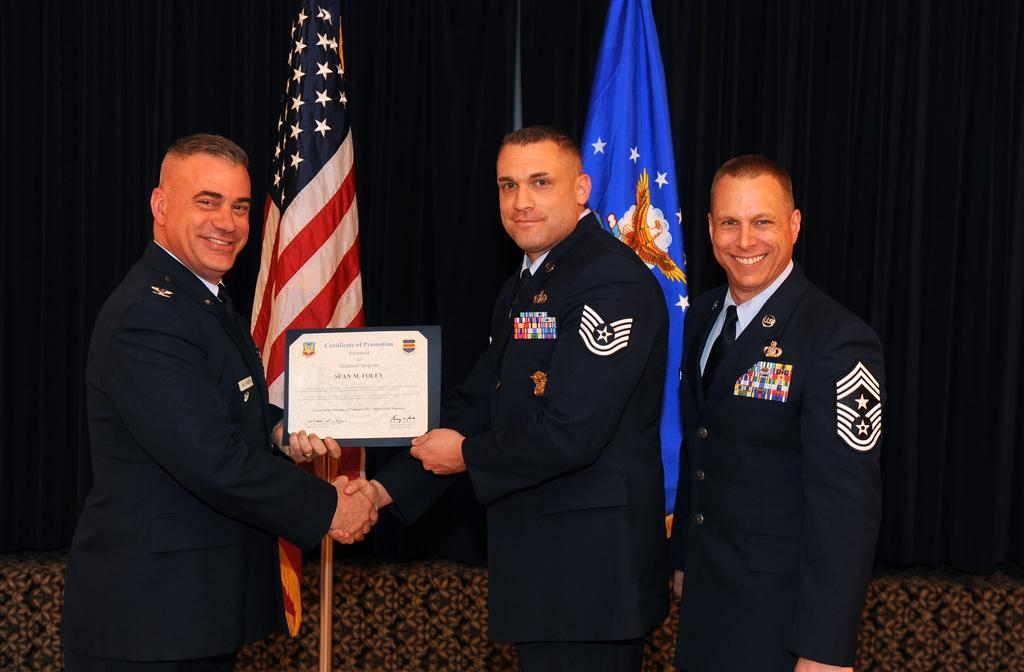How many people are in the image? There are three men in the image. What are the men doing in the image? The men are posing for a camera and smiling. What are the men holding in the image? The men are holding a frame with their hands. What can be seen in the background of the image? There are flags and curtains in the background of the image. What type of squirrel can be seen climbing the frame in the image? There is no squirrel present in the image; the men are holding a frame with their hands. What kind of popcorn is being served in the image? There is no popcorn present in the image; the men are holding a frame and posing for a camera. 